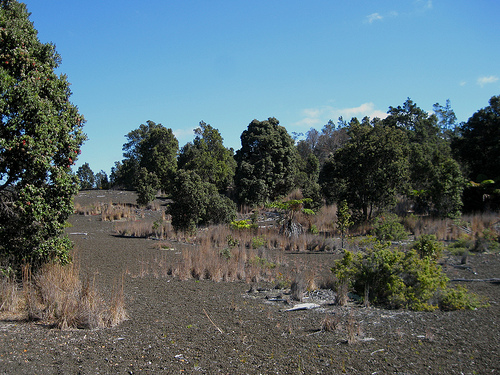<image>
Can you confirm if the tree is on the grass? No. The tree is not positioned on the grass. They may be near each other, but the tree is not supported by or resting on top of the grass. 